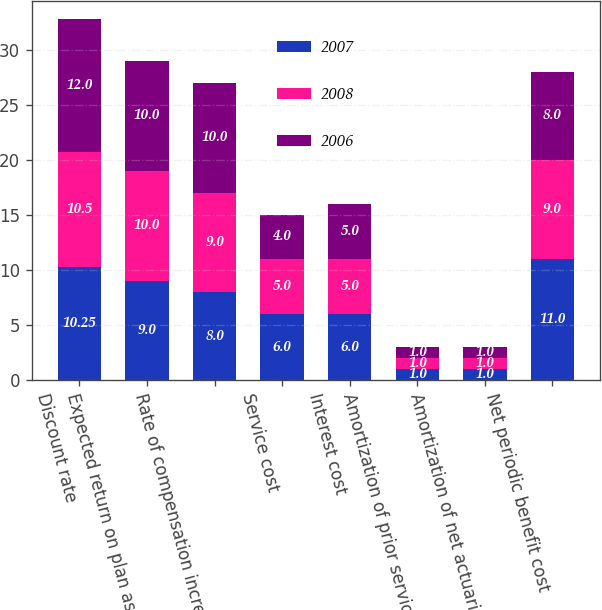<chart> <loc_0><loc_0><loc_500><loc_500><stacked_bar_chart><ecel><fcel>Discount rate<fcel>Expected return on plan assets<fcel>Rate of compensation increase<fcel>Service cost<fcel>Interest cost<fcel>Amortization of prior service<fcel>Amortization of net actuarial<fcel>Net periodic benefit cost<nl><fcel>2007<fcel>10.25<fcel>9<fcel>8<fcel>6<fcel>6<fcel>1<fcel>1<fcel>11<nl><fcel>2008<fcel>10.5<fcel>10<fcel>9<fcel>5<fcel>5<fcel>1<fcel>1<fcel>9<nl><fcel>2006<fcel>12<fcel>10<fcel>10<fcel>4<fcel>5<fcel>1<fcel>1<fcel>8<nl></chart> 